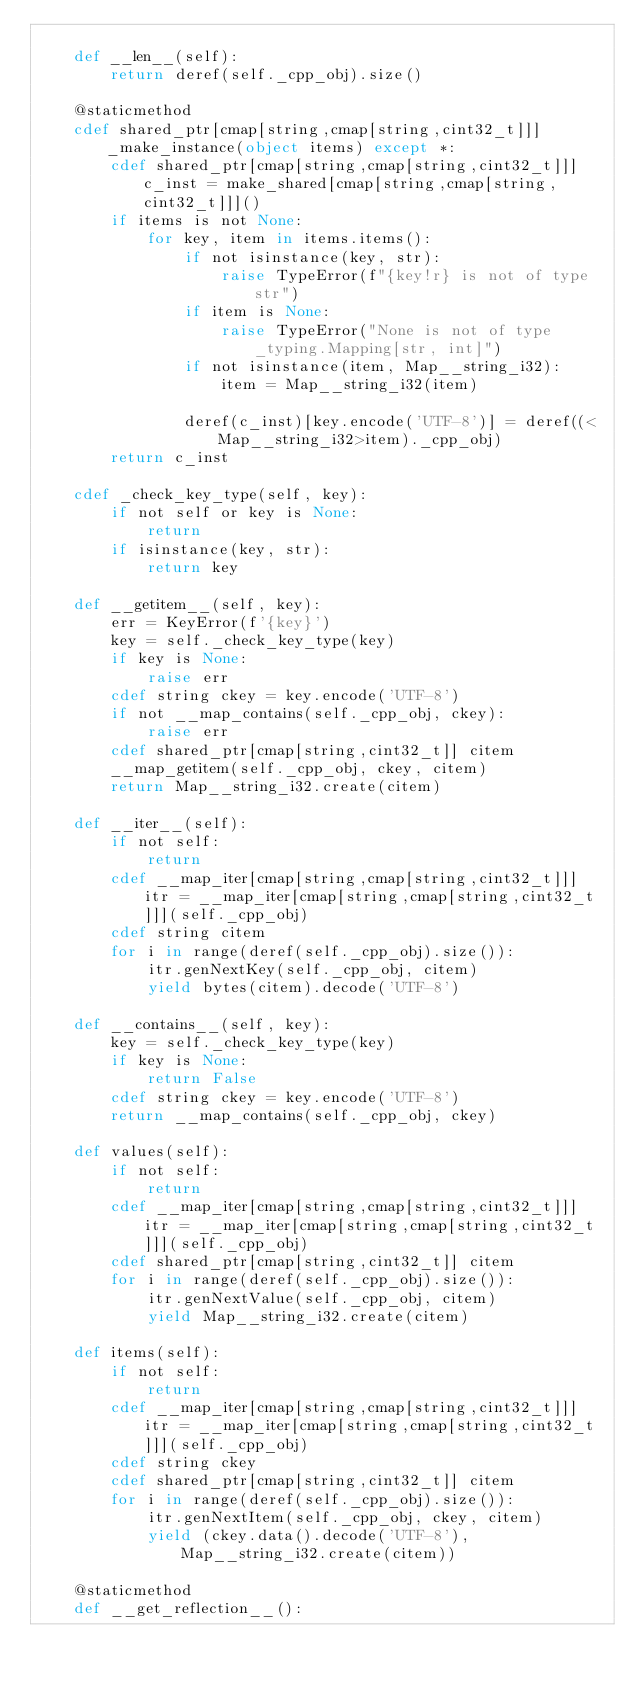<code> <loc_0><loc_0><loc_500><loc_500><_Cython_>
    def __len__(self):
        return deref(self._cpp_obj).size()

    @staticmethod
    cdef shared_ptr[cmap[string,cmap[string,cint32_t]]] _make_instance(object items) except *:
        cdef shared_ptr[cmap[string,cmap[string,cint32_t]]] c_inst = make_shared[cmap[string,cmap[string,cint32_t]]]()
        if items is not None:
            for key, item in items.items():
                if not isinstance(key, str):
                    raise TypeError(f"{key!r} is not of type str")
                if item is None:
                    raise TypeError("None is not of type _typing.Mapping[str, int]")
                if not isinstance(item, Map__string_i32):
                    item = Map__string_i32(item)

                deref(c_inst)[key.encode('UTF-8')] = deref((<Map__string_i32>item)._cpp_obj)
        return c_inst

    cdef _check_key_type(self, key):
        if not self or key is None:
            return
        if isinstance(key, str):
            return key

    def __getitem__(self, key):
        err = KeyError(f'{key}')
        key = self._check_key_type(key)
        if key is None:
            raise err
        cdef string ckey = key.encode('UTF-8')
        if not __map_contains(self._cpp_obj, ckey):
            raise err
        cdef shared_ptr[cmap[string,cint32_t]] citem
        __map_getitem(self._cpp_obj, ckey, citem)
        return Map__string_i32.create(citem)

    def __iter__(self):
        if not self:
            return
        cdef __map_iter[cmap[string,cmap[string,cint32_t]]] itr = __map_iter[cmap[string,cmap[string,cint32_t]]](self._cpp_obj)
        cdef string citem
        for i in range(deref(self._cpp_obj).size()):
            itr.genNextKey(self._cpp_obj, citem)
            yield bytes(citem).decode('UTF-8')

    def __contains__(self, key):
        key = self._check_key_type(key)
        if key is None:
            return False
        cdef string ckey = key.encode('UTF-8')
        return __map_contains(self._cpp_obj, ckey)

    def values(self):
        if not self:
            return
        cdef __map_iter[cmap[string,cmap[string,cint32_t]]] itr = __map_iter[cmap[string,cmap[string,cint32_t]]](self._cpp_obj)
        cdef shared_ptr[cmap[string,cint32_t]] citem
        for i in range(deref(self._cpp_obj).size()):
            itr.genNextValue(self._cpp_obj, citem)
            yield Map__string_i32.create(citem)

    def items(self):
        if not self:
            return
        cdef __map_iter[cmap[string,cmap[string,cint32_t]]] itr = __map_iter[cmap[string,cmap[string,cint32_t]]](self._cpp_obj)
        cdef string ckey
        cdef shared_ptr[cmap[string,cint32_t]] citem
        for i in range(deref(self._cpp_obj).size()):
            itr.genNextItem(self._cpp_obj, ckey, citem)
            yield (ckey.data().decode('UTF-8'), Map__string_i32.create(citem))

    @staticmethod
    def __get_reflection__():</code> 